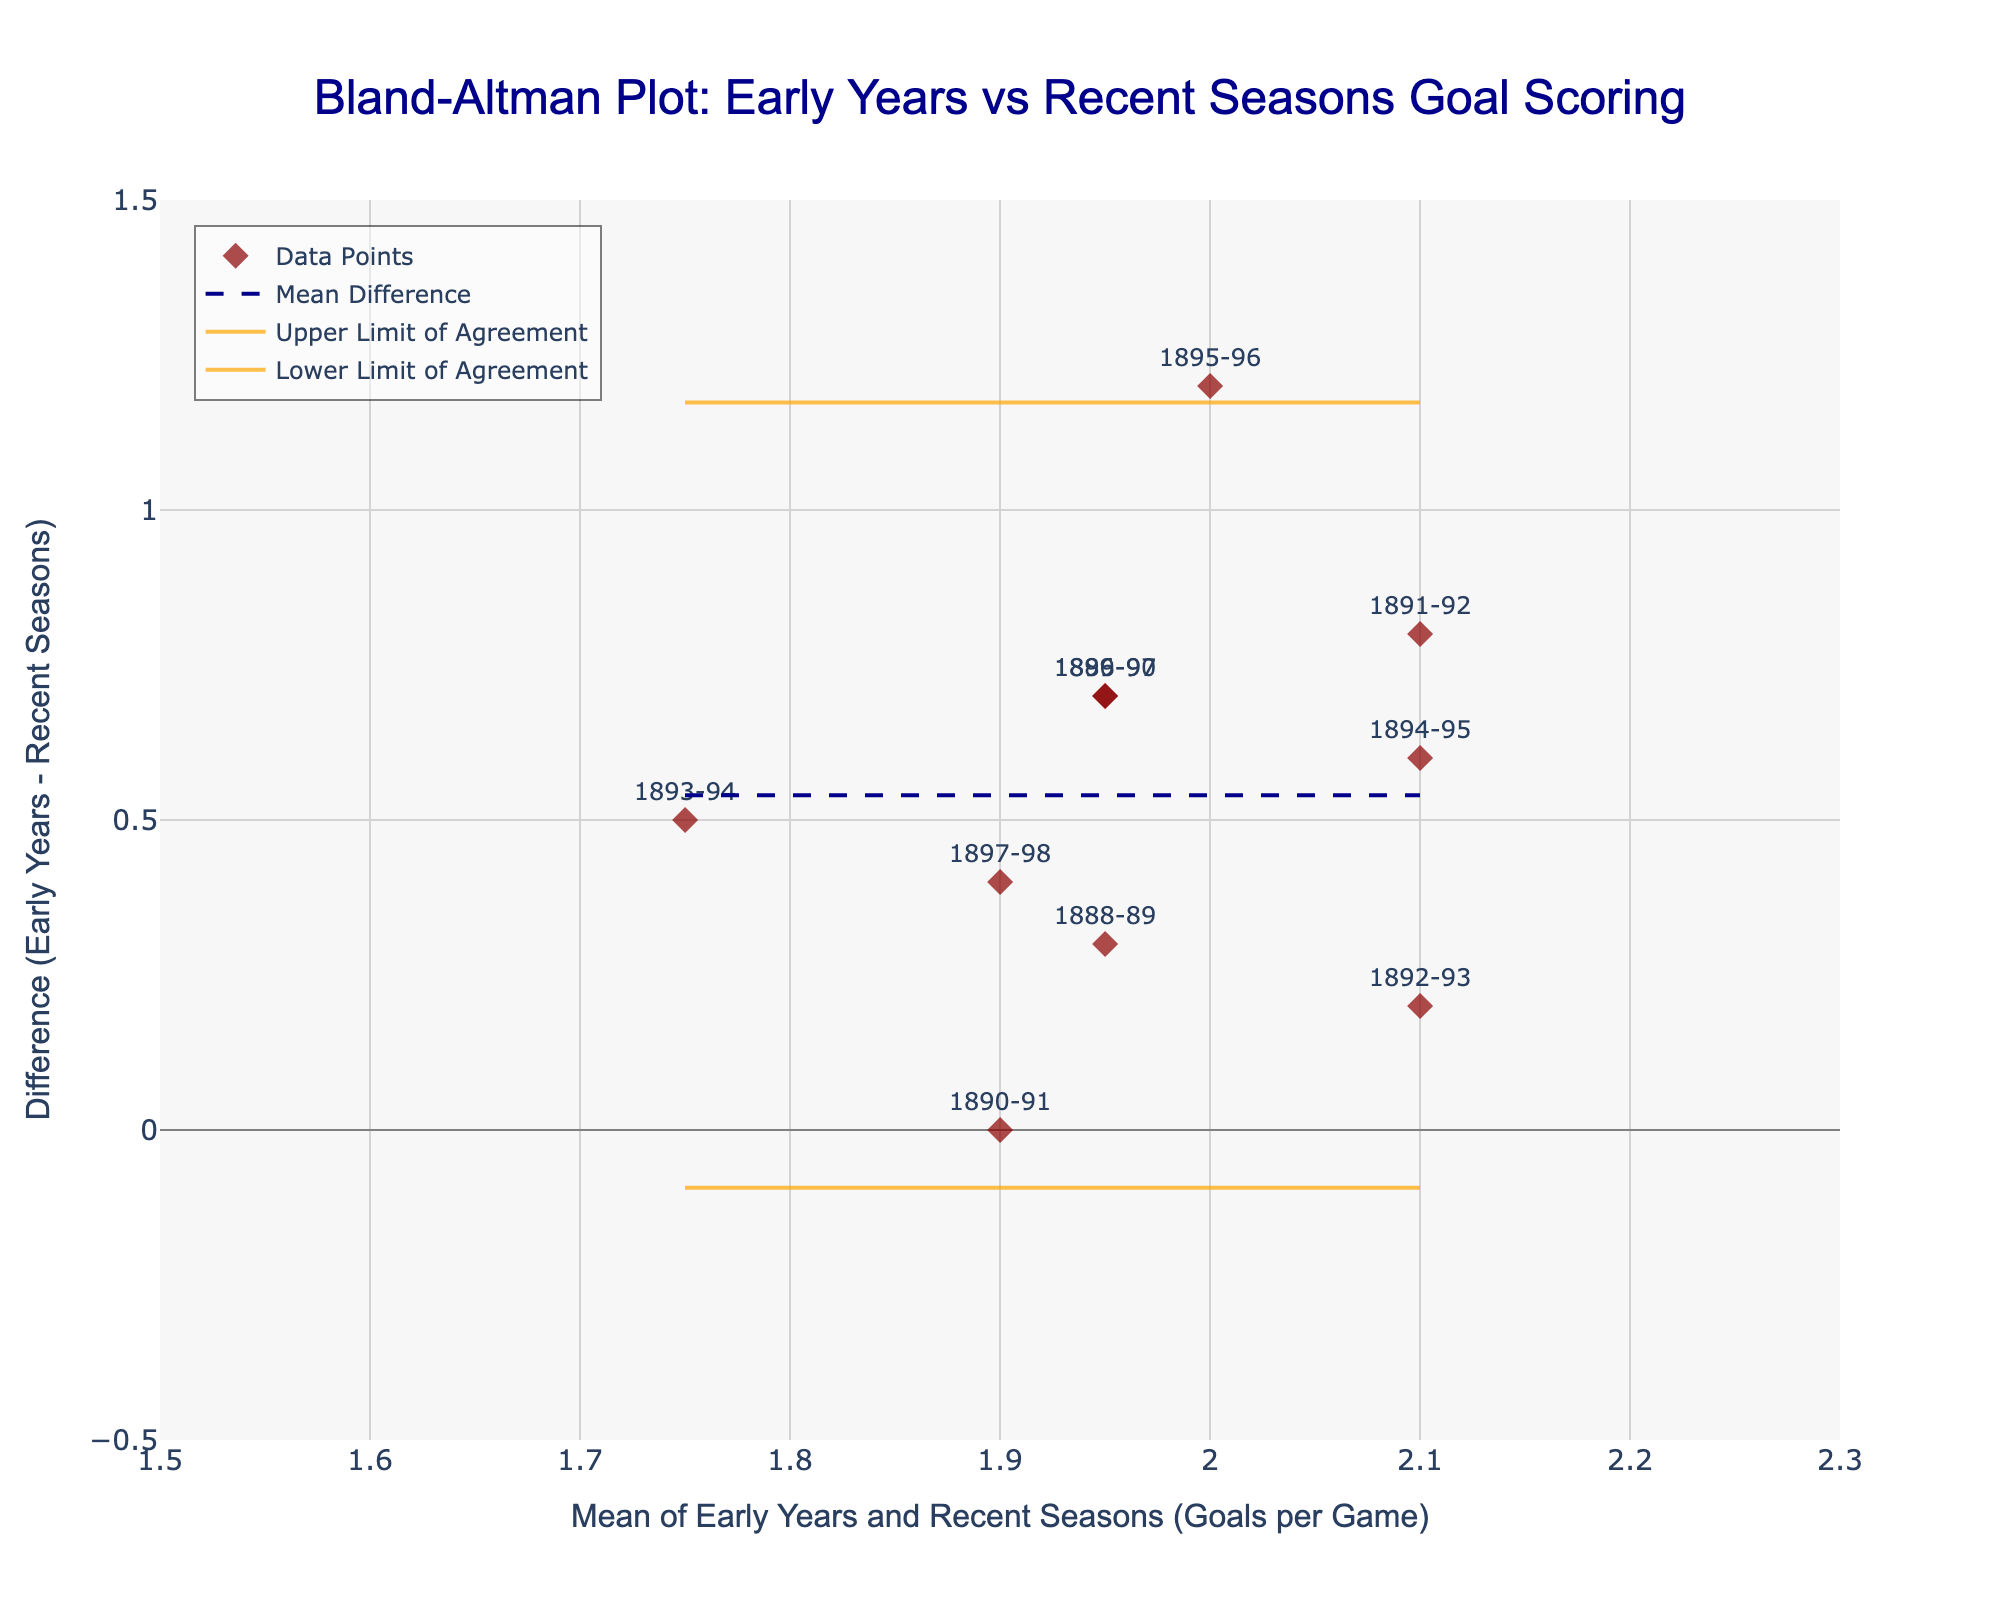How many data points are displayed in the plot? There are ten seasons displayed as data points on the Bland-Altman plot. Each data point corresponds to a season from 1888-89 to 1897-98.
Answer: 10 Which season has the highest mean goals per game between early years and recent seasons? From the plot, locate the data point with the highest value on the x-axis (mean goals per game). The season with the highest x-axis value is 1891-92 with a mean of 2.1 goals per game.
Answer: 1891-92 What is the range of the differences between the early years and recent seasons goals per game? To find the range, identify the maximum and minimum values on the y-axis (difference in goals per game). The maximum difference is about 1.2, and the minimum is around 0.
Answer: 0 to 1.2 What does the mean difference line represent, and where is it located on the y-axis? The mean difference line represents the average difference in goals per game between the early years and the recent seasons. It is located at 0.55 on the y-axis, indicating that, on average, the early years had 0.55 more goals per game.
Answer: 0.55 Are there any data points outside the limits of agreement? The limits of agreement are represented by the upper and lower orange lines. No data points fall outside these lines, as all points are within the bounds of -0.18 (lower limit) and 1.28 (upper limit).
Answer: No What is the mean value of goals per game for the 1892-93 season? Identify the 1892-93 season on the plot, which is represented by a specific point. The x-coordinate of this point represents the mean, which is 2.1 goals per game.
Answer: 2.1 How many seasons have a positive difference between early years and recent seasons goals per game? Count the number of data points located above the y-axis (positive difference). There are 7 data points above the y-axis, indicating 7 seasons with a positive difference.
Answer: 7 What is the difference in goals per game for the season 1895-96? Locate the data point for the 1895-96 season and read the value on the y-axis, which represents the difference. The difference for this season is approximately 1.2.
Answer: 1.2 Does any season have an equal goal-scoring rate between early years and recent seasons? Check for any data points that fall exactly on the y-axis value of 0 (where the difference is zero). The 1890-91 season has a difference of 0, meaning equal goal-scoring rates.
Answer: Yes, 1890-91 What are the upper and lower limits of agreement, and what do they signify? The upper limit of agreement is 1.28 and the lower limit is -0.18. These limits signify the range within which most differences between early and recent goal-scoring rates are expected to fall, considering random variations.
Answer: 1.28 (upper), -0.18 (lower) 